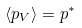Convert formula to latex. <formula><loc_0><loc_0><loc_500><loc_500>\left < p _ { V } \right > = p ^ { * }</formula> 